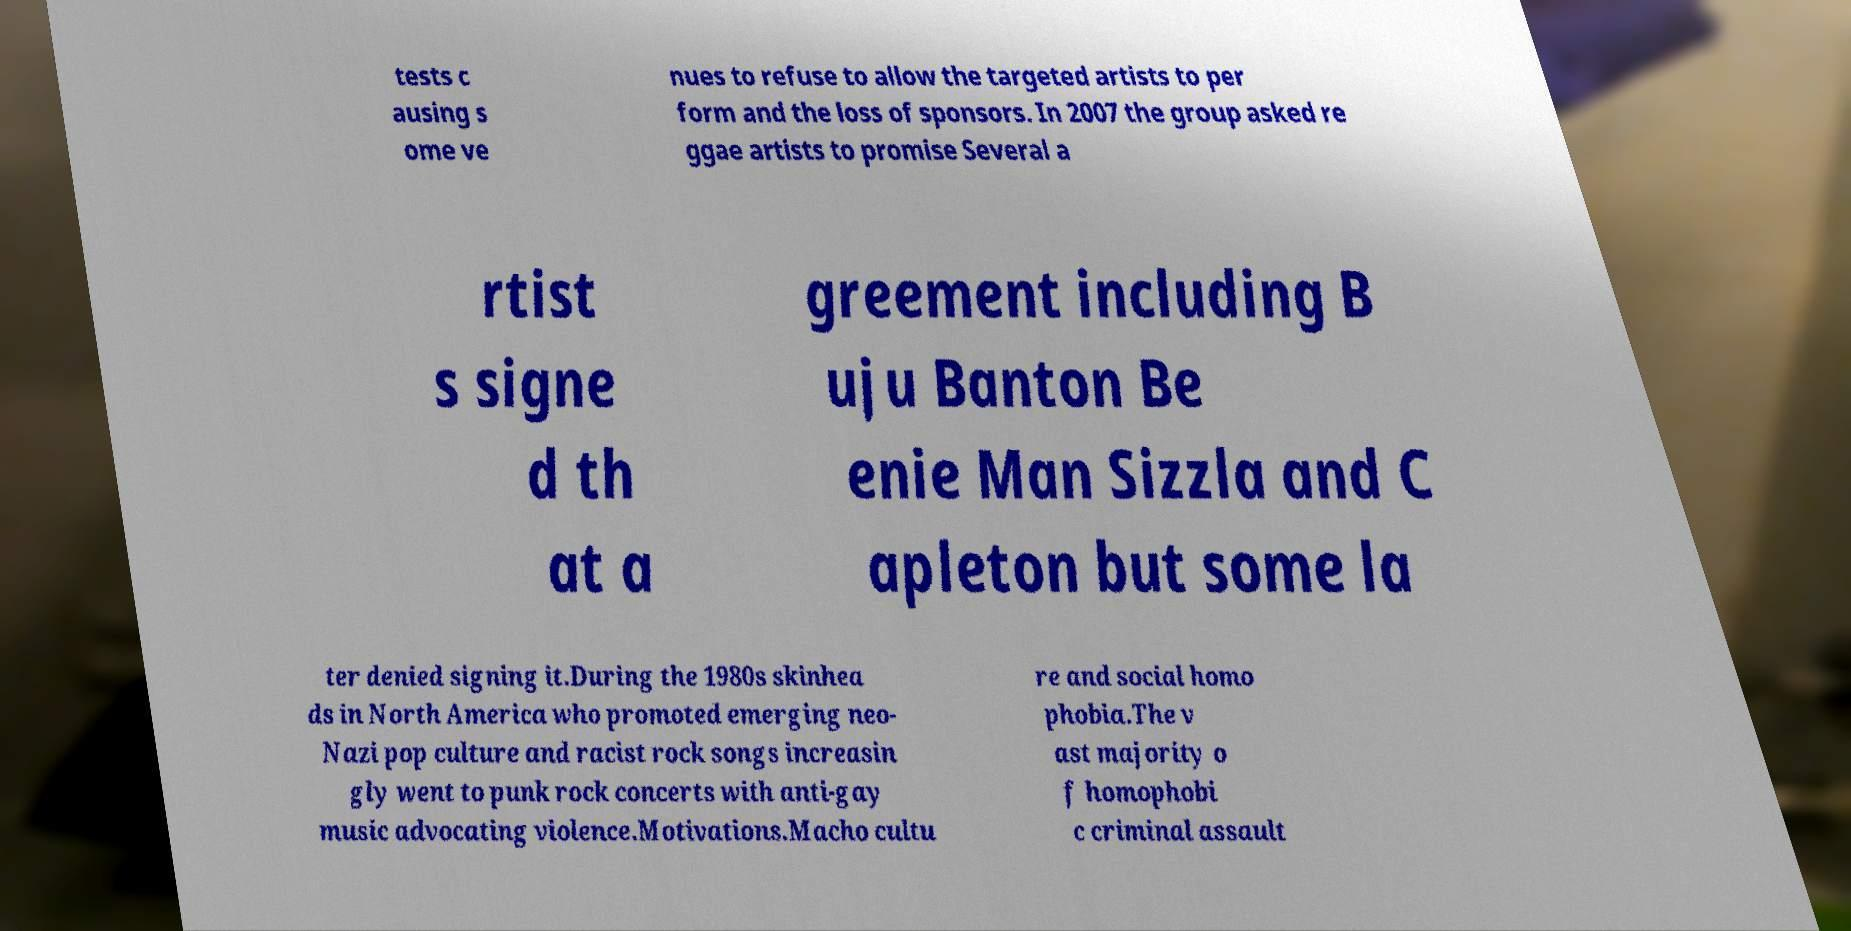For documentation purposes, I need the text within this image transcribed. Could you provide that? tests c ausing s ome ve nues to refuse to allow the targeted artists to per form and the loss of sponsors. In 2007 the group asked re ggae artists to promise Several a rtist s signe d th at a greement including B uju Banton Be enie Man Sizzla and C apleton but some la ter denied signing it.During the 1980s skinhea ds in North America who promoted emerging neo- Nazi pop culture and racist rock songs increasin gly went to punk rock concerts with anti-gay music advocating violence.Motivations.Macho cultu re and social homo phobia.The v ast majority o f homophobi c criminal assault 